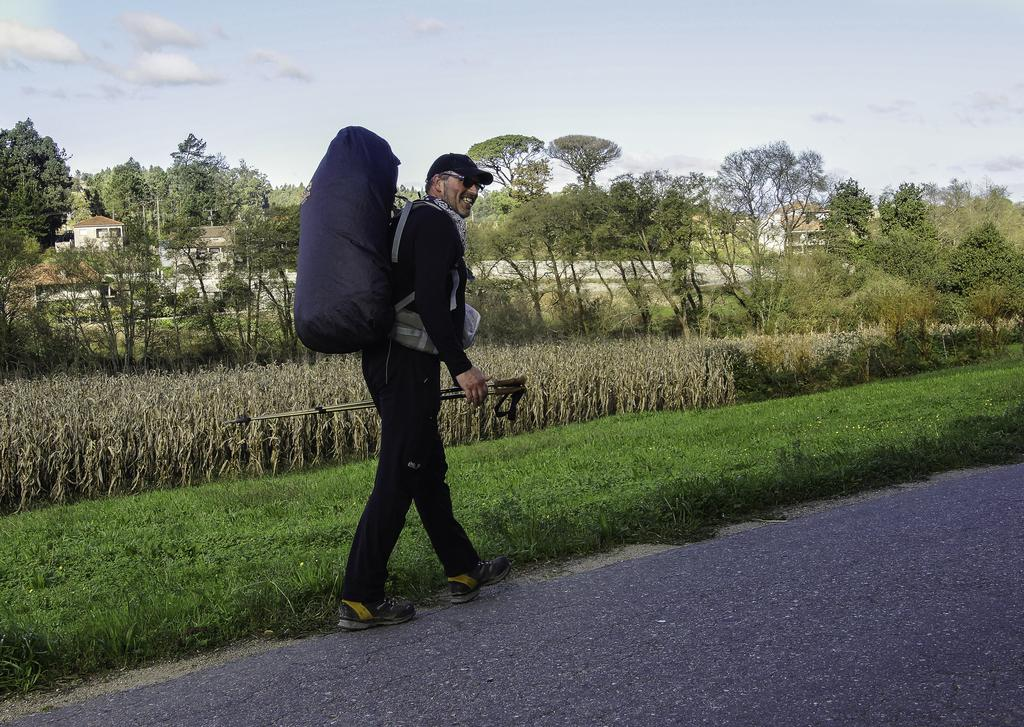What is the main subject of the image? There is a man in the image. What is the man doing in the image? The man is walking. What is the man carrying on his back? The man is wearing a backpack. What can be seen in the background of the image? There is grass, trees, buildings, and the sky visible in the background of the image. What is present at the bottom of the image? There is grass at the bottom of the image. What type of feast is being prepared in the image? There is no feast or any indication of food preparation in the image. What holiday is being celebrated in the image? There is no indication of a holiday being celebrated in the image. 